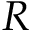<formula> <loc_0><loc_0><loc_500><loc_500>R</formula> 